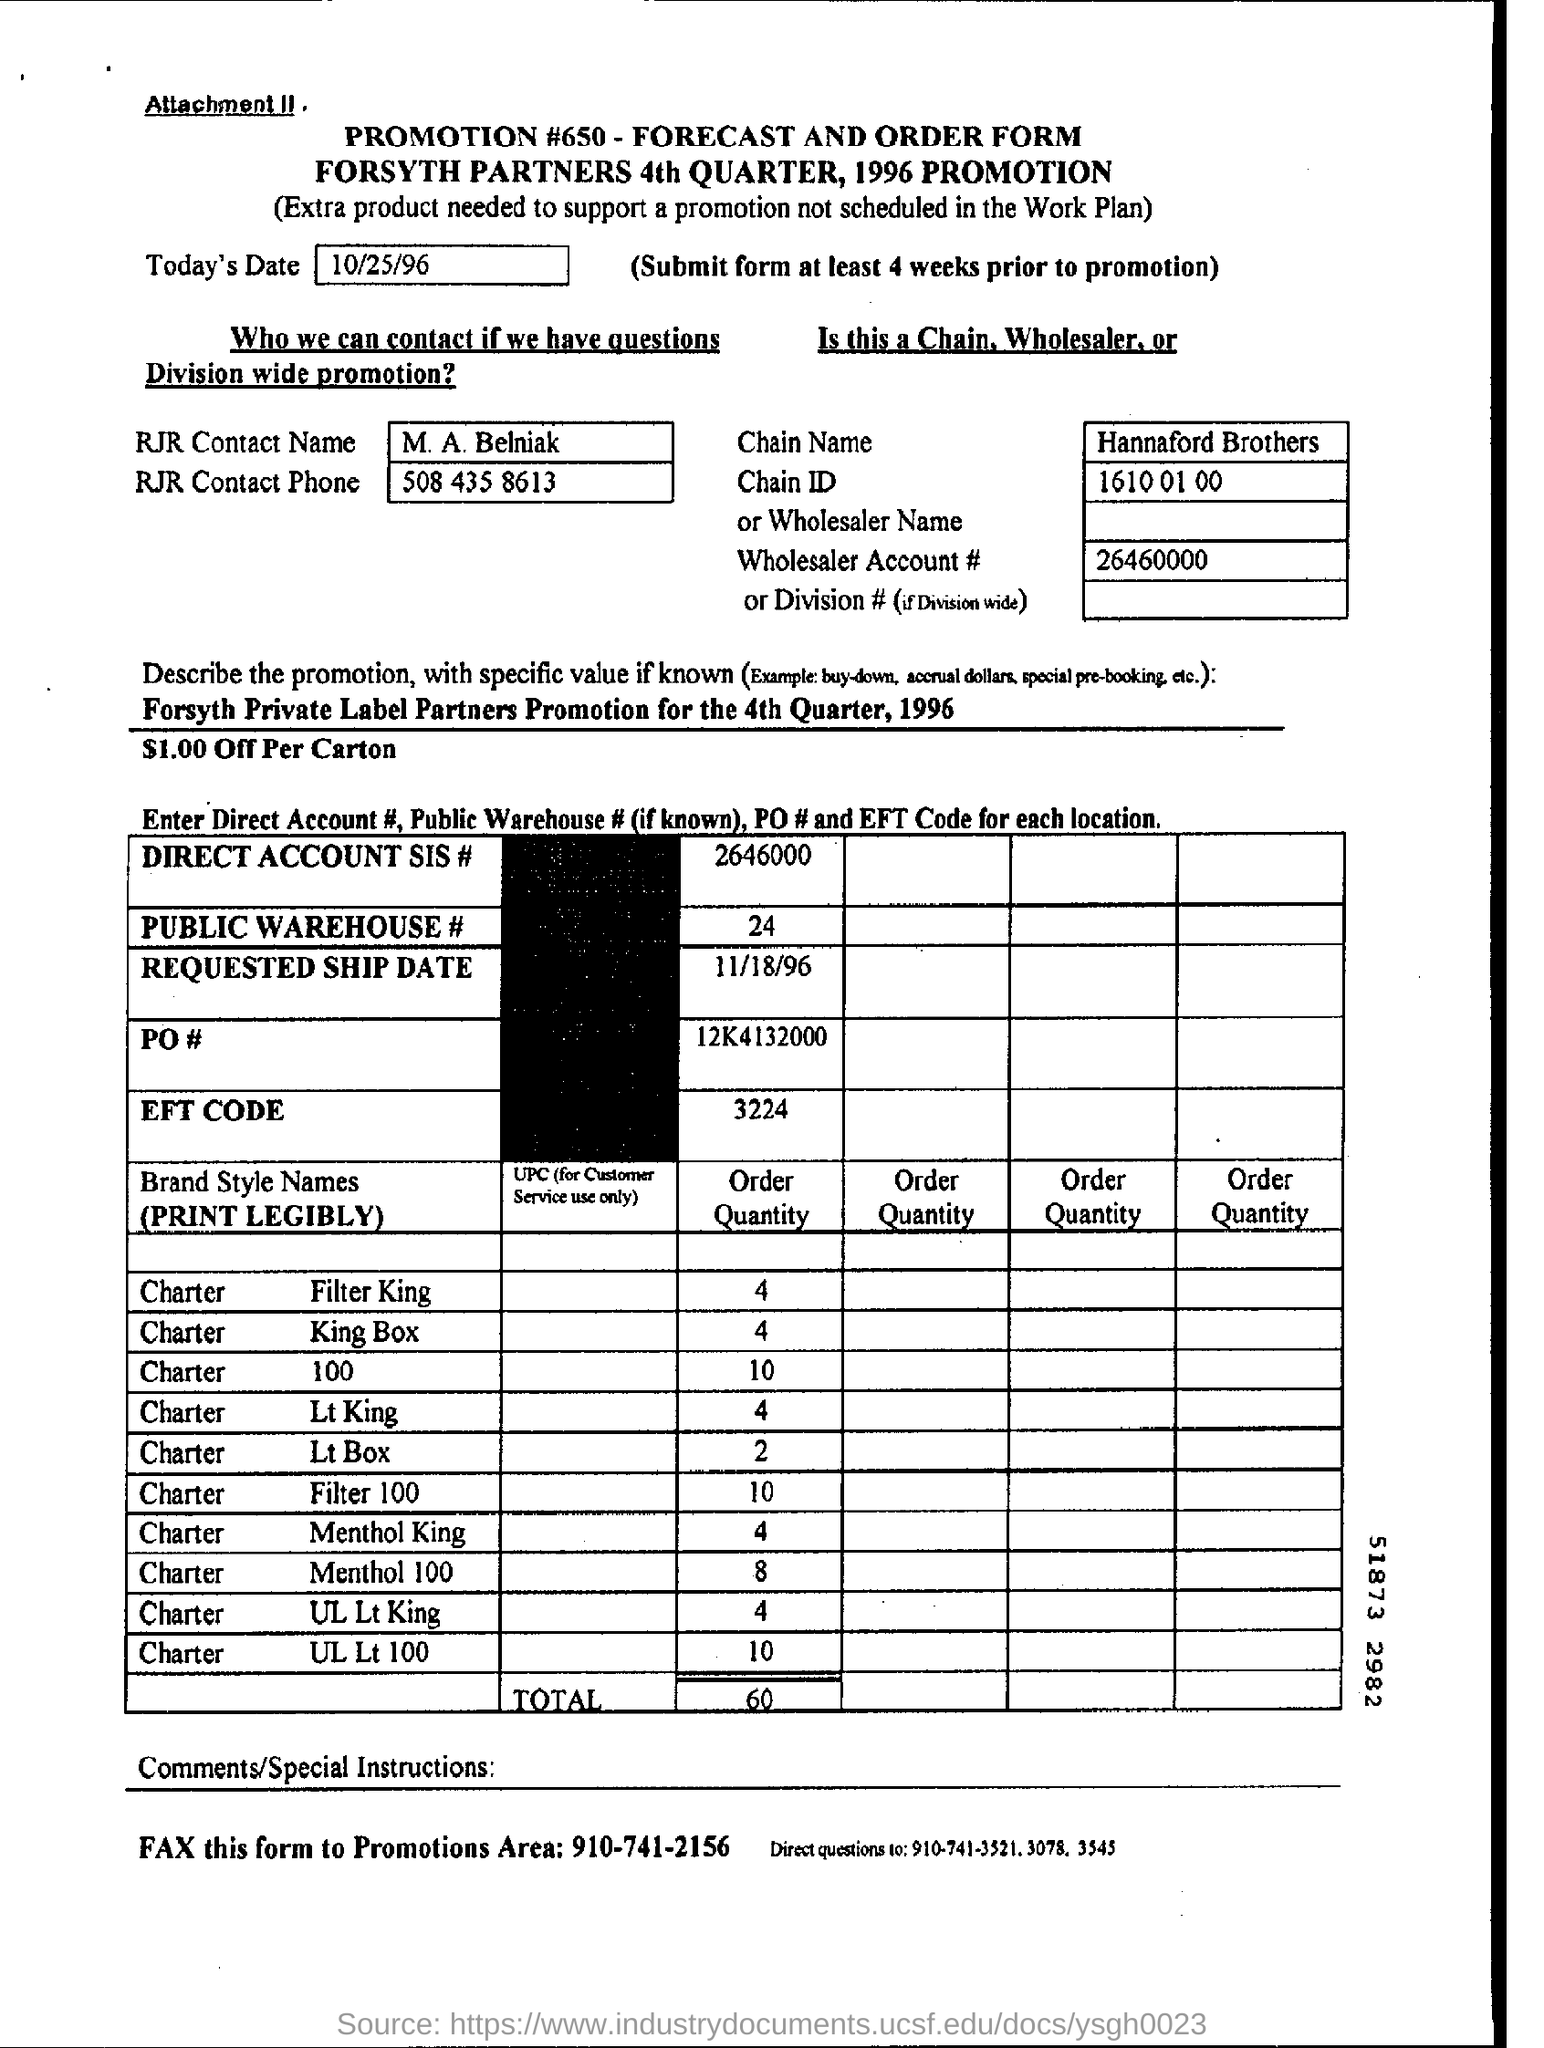Identify some key points in this picture. The name of the RJR contact person is M. A. Belniak. The promotion number mentioned on the form is #650. The forecast and order form are dated October 25, 1996. The total order quantity is 60. 